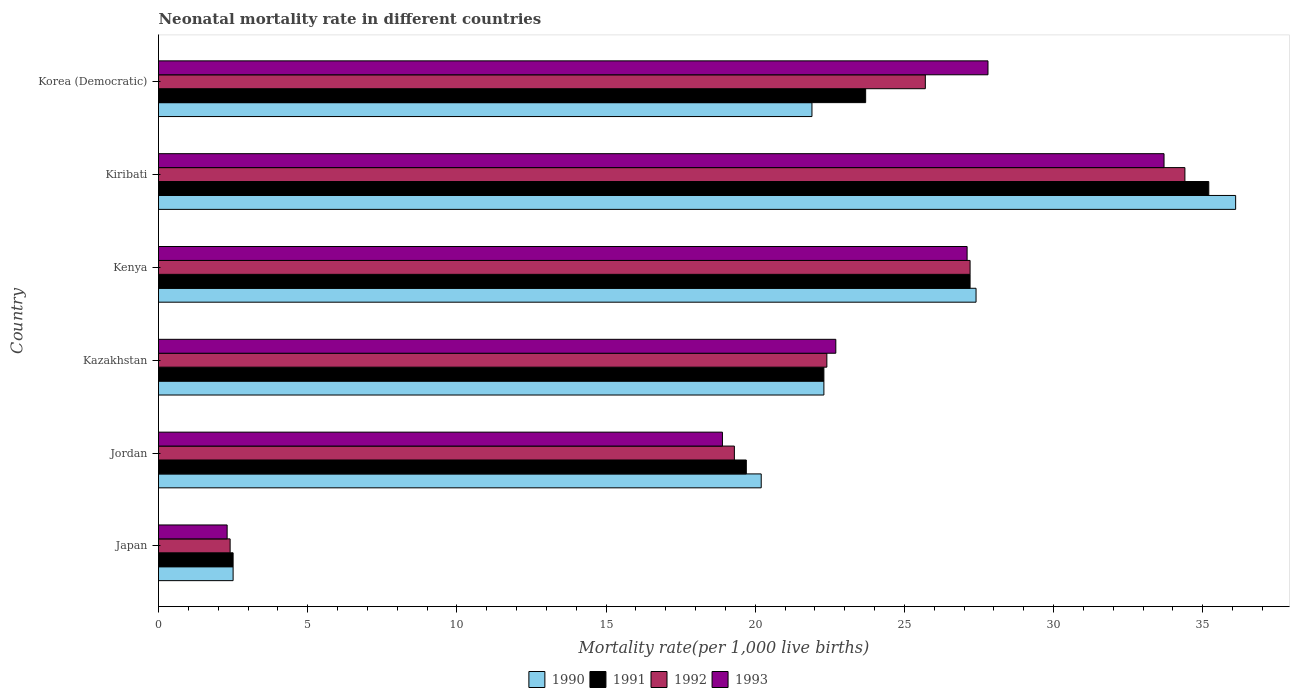Are the number of bars per tick equal to the number of legend labels?
Your response must be concise. Yes. How many bars are there on the 1st tick from the bottom?
Give a very brief answer. 4. What is the label of the 5th group of bars from the top?
Provide a succinct answer. Jordan. What is the neonatal mortality rate in 1992 in Jordan?
Keep it short and to the point. 19.3. Across all countries, what is the maximum neonatal mortality rate in 1993?
Give a very brief answer. 33.7. Across all countries, what is the minimum neonatal mortality rate in 1991?
Offer a terse response. 2.5. In which country was the neonatal mortality rate in 1993 maximum?
Offer a terse response. Kiribati. What is the total neonatal mortality rate in 1993 in the graph?
Provide a succinct answer. 132.5. What is the difference between the neonatal mortality rate in 1991 in Japan and that in Jordan?
Your response must be concise. -17.2. What is the average neonatal mortality rate in 1990 per country?
Make the answer very short. 21.73. What is the difference between the neonatal mortality rate in 1991 and neonatal mortality rate in 1992 in Kenya?
Your answer should be compact. 0. What is the ratio of the neonatal mortality rate in 1993 in Kenya to that in Korea (Democratic)?
Your response must be concise. 0.97. Is the neonatal mortality rate in 1990 in Jordan less than that in Korea (Democratic)?
Provide a short and direct response. Yes. Is the difference between the neonatal mortality rate in 1991 in Japan and Kazakhstan greater than the difference between the neonatal mortality rate in 1992 in Japan and Kazakhstan?
Your answer should be compact. Yes. What is the difference between the highest and the second highest neonatal mortality rate in 1992?
Give a very brief answer. 7.2. What is the difference between the highest and the lowest neonatal mortality rate in 1993?
Keep it short and to the point. 31.4. In how many countries, is the neonatal mortality rate in 1993 greater than the average neonatal mortality rate in 1993 taken over all countries?
Your response must be concise. 4. Is the sum of the neonatal mortality rate in 1993 in Kenya and Kiribati greater than the maximum neonatal mortality rate in 1992 across all countries?
Offer a terse response. Yes. What does the 3rd bar from the bottom in Japan represents?
Ensure brevity in your answer.  1992. Is it the case that in every country, the sum of the neonatal mortality rate in 1990 and neonatal mortality rate in 1992 is greater than the neonatal mortality rate in 1991?
Provide a short and direct response. Yes. What is the difference between two consecutive major ticks on the X-axis?
Your answer should be compact. 5. Does the graph contain grids?
Give a very brief answer. No. How many legend labels are there?
Offer a terse response. 4. What is the title of the graph?
Keep it short and to the point. Neonatal mortality rate in different countries. Does "2000" appear as one of the legend labels in the graph?
Provide a short and direct response. No. What is the label or title of the X-axis?
Provide a succinct answer. Mortality rate(per 1,0 live births). What is the label or title of the Y-axis?
Make the answer very short. Country. What is the Mortality rate(per 1,000 live births) of 1990 in Japan?
Offer a terse response. 2.5. What is the Mortality rate(per 1,000 live births) in 1993 in Japan?
Keep it short and to the point. 2.3. What is the Mortality rate(per 1,000 live births) in 1990 in Jordan?
Ensure brevity in your answer.  20.2. What is the Mortality rate(per 1,000 live births) of 1991 in Jordan?
Offer a very short reply. 19.7. What is the Mortality rate(per 1,000 live births) in 1992 in Jordan?
Give a very brief answer. 19.3. What is the Mortality rate(per 1,000 live births) of 1990 in Kazakhstan?
Give a very brief answer. 22.3. What is the Mortality rate(per 1,000 live births) in 1991 in Kazakhstan?
Your answer should be compact. 22.3. What is the Mortality rate(per 1,000 live births) in 1992 in Kazakhstan?
Your answer should be compact. 22.4. What is the Mortality rate(per 1,000 live births) in 1993 in Kazakhstan?
Provide a succinct answer. 22.7. What is the Mortality rate(per 1,000 live births) of 1990 in Kenya?
Provide a short and direct response. 27.4. What is the Mortality rate(per 1,000 live births) of 1991 in Kenya?
Your answer should be very brief. 27.2. What is the Mortality rate(per 1,000 live births) in 1992 in Kenya?
Make the answer very short. 27.2. What is the Mortality rate(per 1,000 live births) of 1993 in Kenya?
Make the answer very short. 27.1. What is the Mortality rate(per 1,000 live births) in 1990 in Kiribati?
Give a very brief answer. 36.1. What is the Mortality rate(per 1,000 live births) in 1991 in Kiribati?
Keep it short and to the point. 35.2. What is the Mortality rate(per 1,000 live births) in 1992 in Kiribati?
Provide a short and direct response. 34.4. What is the Mortality rate(per 1,000 live births) in 1993 in Kiribati?
Your response must be concise. 33.7. What is the Mortality rate(per 1,000 live births) in 1990 in Korea (Democratic)?
Provide a succinct answer. 21.9. What is the Mortality rate(per 1,000 live births) in 1991 in Korea (Democratic)?
Provide a succinct answer. 23.7. What is the Mortality rate(per 1,000 live births) of 1992 in Korea (Democratic)?
Ensure brevity in your answer.  25.7. What is the Mortality rate(per 1,000 live births) in 1993 in Korea (Democratic)?
Your response must be concise. 27.8. Across all countries, what is the maximum Mortality rate(per 1,000 live births) in 1990?
Your answer should be compact. 36.1. Across all countries, what is the maximum Mortality rate(per 1,000 live births) of 1991?
Keep it short and to the point. 35.2. Across all countries, what is the maximum Mortality rate(per 1,000 live births) of 1992?
Your answer should be compact. 34.4. Across all countries, what is the maximum Mortality rate(per 1,000 live births) in 1993?
Offer a terse response. 33.7. Across all countries, what is the minimum Mortality rate(per 1,000 live births) in 1990?
Make the answer very short. 2.5. What is the total Mortality rate(per 1,000 live births) in 1990 in the graph?
Your answer should be very brief. 130.4. What is the total Mortality rate(per 1,000 live births) of 1991 in the graph?
Provide a succinct answer. 130.6. What is the total Mortality rate(per 1,000 live births) of 1992 in the graph?
Give a very brief answer. 131.4. What is the total Mortality rate(per 1,000 live births) of 1993 in the graph?
Your answer should be very brief. 132.5. What is the difference between the Mortality rate(per 1,000 live births) in 1990 in Japan and that in Jordan?
Provide a succinct answer. -17.7. What is the difference between the Mortality rate(per 1,000 live births) of 1991 in Japan and that in Jordan?
Your response must be concise. -17.2. What is the difference between the Mortality rate(per 1,000 live births) in 1992 in Japan and that in Jordan?
Your response must be concise. -16.9. What is the difference between the Mortality rate(per 1,000 live births) in 1993 in Japan and that in Jordan?
Keep it short and to the point. -16.6. What is the difference between the Mortality rate(per 1,000 live births) of 1990 in Japan and that in Kazakhstan?
Give a very brief answer. -19.8. What is the difference between the Mortality rate(per 1,000 live births) in 1991 in Japan and that in Kazakhstan?
Your answer should be very brief. -19.8. What is the difference between the Mortality rate(per 1,000 live births) of 1992 in Japan and that in Kazakhstan?
Offer a very short reply. -20. What is the difference between the Mortality rate(per 1,000 live births) in 1993 in Japan and that in Kazakhstan?
Give a very brief answer. -20.4. What is the difference between the Mortality rate(per 1,000 live births) of 1990 in Japan and that in Kenya?
Your response must be concise. -24.9. What is the difference between the Mortality rate(per 1,000 live births) of 1991 in Japan and that in Kenya?
Offer a very short reply. -24.7. What is the difference between the Mortality rate(per 1,000 live births) of 1992 in Japan and that in Kenya?
Give a very brief answer. -24.8. What is the difference between the Mortality rate(per 1,000 live births) in 1993 in Japan and that in Kenya?
Your response must be concise. -24.8. What is the difference between the Mortality rate(per 1,000 live births) in 1990 in Japan and that in Kiribati?
Provide a short and direct response. -33.6. What is the difference between the Mortality rate(per 1,000 live births) in 1991 in Japan and that in Kiribati?
Your response must be concise. -32.7. What is the difference between the Mortality rate(per 1,000 live births) in 1992 in Japan and that in Kiribati?
Provide a short and direct response. -32. What is the difference between the Mortality rate(per 1,000 live births) of 1993 in Japan and that in Kiribati?
Your response must be concise. -31.4. What is the difference between the Mortality rate(per 1,000 live births) of 1990 in Japan and that in Korea (Democratic)?
Ensure brevity in your answer.  -19.4. What is the difference between the Mortality rate(per 1,000 live births) of 1991 in Japan and that in Korea (Democratic)?
Your response must be concise. -21.2. What is the difference between the Mortality rate(per 1,000 live births) in 1992 in Japan and that in Korea (Democratic)?
Ensure brevity in your answer.  -23.3. What is the difference between the Mortality rate(per 1,000 live births) in 1993 in Japan and that in Korea (Democratic)?
Provide a succinct answer. -25.5. What is the difference between the Mortality rate(per 1,000 live births) in 1990 in Jordan and that in Kazakhstan?
Give a very brief answer. -2.1. What is the difference between the Mortality rate(per 1,000 live births) in 1991 in Jordan and that in Kazakhstan?
Offer a very short reply. -2.6. What is the difference between the Mortality rate(per 1,000 live births) of 1992 in Jordan and that in Kazakhstan?
Provide a short and direct response. -3.1. What is the difference between the Mortality rate(per 1,000 live births) in 1991 in Jordan and that in Kenya?
Make the answer very short. -7.5. What is the difference between the Mortality rate(per 1,000 live births) in 1992 in Jordan and that in Kenya?
Offer a very short reply. -7.9. What is the difference between the Mortality rate(per 1,000 live births) in 1993 in Jordan and that in Kenya?
Your answer should be very brief. -8.2. What is the difference between the Mortality rate(per 1,000 live births) of 1990 in Jordan and that in Kiribati?
Your answer should be compact. -15.9. What is the difference between the Mortality rate(per 1,000 live births) in 1991 in Jordan and that in Kiribati?
Offer a terse response. -15.5. What is the difference between the Mortality rate(per 1,000 live births) of 1992 in Jordan and that in Kiribati?
Keep it short and to the point. -15.1. What is the difference between the Mortality rate(per 1,000 live births) in 1993 in Jordan and that in Kiribati?
Make the answer very short. -14.8. What is the difference between the Mortality rate(per 1,000 live births) of 1990 in Jordan and that in Korea (Democratic)?
Your answer should be compact. -1.7. What is the difference between the Mortality rate(per 1,000 live births) in 1991 in Jordan and that in Korea (Democratic)?
Ensure brevity in your answer.  -4. What is the difference between the Mortality rate(per 1,000 live births) of 1992 in Kazakhstan and that in Kenya?
Offer a terse response. -4.8. What is the difference between the Mortality rate(per 1,000 live births) in 1992 in Kazakhstan and that in Kiribati?
Give a very brief answer. -12. What is the difference between the Mortality rate(per 1,000 live births) in 1993 in Kazakhstan and that in Kiribati?
Provide a succinct answer. -11. What is the difference between the Mortality rate(per 1,000 live births) in 1990 in Kazakhstan and that in Korea (Democratic)?
Offer a terse response. 0.4. What is the difference between the Mortality rate(per 1,000 live births) in 1991 in Kazakhstan and that in Korea (Democratic)?
Offer a terse response. -1.4. What is the difference between the Mortality rate(per 1,000 live births) of 1992 in Kazakhstan and that in Korea (Democratic)?
Your response must be concise. -3.3. What is the difference between the Mortality rate(per 1,000 live births) in 1993 in Kazakhstan and that in Korea (Democratic)?
Provide a succinct answer. -5.1. What is the difference between the Mortality rate(per 1,000 live births) in 1992 in Kenya and that in Kiribati?
Make the answer very short. -7.2. What is the difference between the Mortality rate(per 1,000 live births) of 1993 in Kenya and that in Kiribati?
Offer a terse response. -6.6. What is the difference between the Mortality rate(per 1,000 live births) of 1991 in Kenya and that in Korea (Democratic)?
Your answer should be very brief. 3.5. What is the difference between the Mortality rate(per 1,000 live births) of 1992 in Kenya and that in Korea (Democratic)?
Keep it short and to the point. 1.5. What is the difference between the Mortality rate(per 1,000 live births) in 1993 in Kenya and that in Korea (Democratic)?
Offer a terse response. -0.7. What is the difference between the Mortality rate(per 1,000 live births) in 1991 in Kiribati and that in Korea (Democratic)?
Your answer should be very brief. 11.5. What is the difference between the Mortality rate(per 1,000 live births) of 1993 in Kiribati and that in Korea (Democratic)?
Your response must be concise. 5.9. What is the difference between the Mortality rate(per 1,000 live births) of 1990 in Japan and the Mortality rate(per 1,000 live births) of 1991 in Jordan?
Your answer should be compact. -17.2. What is the difference between the Mortality rate(per 1,000 live births) of 1990 in Japan and the Mortality rate(per 1,000 live births) of 1992 in Jordan?
Ensure brevity in your answer.  -16.8. What is the difference between the Mortality rate(per 1,000 live births) in 1990 in Japan and the Mortality rate(per 1,000 live births) in 1993 in Jordan?
Provide a short and direct response. -16.4. What is the difference between the Mortality rate(per 1,000 live births) in 1991 in Japan and the Mortality rate(per 1,000 live births) in 1992 in Jordan?
Your answer should be compact. -16.8. What is the difference between the Mortality rate(per 1,000 live births) in 1991 in Japan and the Mortality rate(per 1,000 live births) in 1993 in Jordan?
Offer a very short reply. -16.4. What is the difference between the Mortality rate(per 1,000 live births) in 1992 in Japan and the Mortality rate(per 1,000 live births) in 1993 in Jordan?
Make the answer very short. -16.5. What is the difference between the Mortality rate(per 1,000 live births) of 1990 in Japan and the Mortality rate(per 1,000 live births) of 1991 in Kazakhstan?
Offer a very short reply. -19.8. What is the difference between the Mortality rate(per 1,000 live births) of 1990 in Japan and the Mortality rate(per 1,000 live births) of 1992 in Kazakhstan?
Provide a short and direct response. -19.9. What is the difference between the Mortality rate(per 1,000 live births) of 1990 in Japan and the Mortality rate(per 1,000 live births) of 1993 in Kazakhstan?
Your answer should be very brief. -20.2. What is the difference between the Mortality rate(per 1,000 live births) in 1991 in Japan and the Mortality rate(per 1,000 live births) in 1992 in Kazakhstan?
Offer a very short reply. -19.9. What is the difference between the Mortality rate(per 1,000 live births) in 1991 in Japan and the Mortality rate(per 1,000 live births) in 1993 in Kazakhstan?
Provide a succinct answer. -20.2. What is the difference between the Mortality rate(per 1,000 live births) in 1992 in Japan and the Mortality rate(per 1,000 live births) in 1993 in Kazakhstan?
Offer a terse response. -20.3. What is the difference between the Mortality rate(per 1,000 live births) in 1990 in Japan and the Mortality rate(per 1,000 live births) in 1991 in Kenya?
Make the answer very short. -24.7. What is the difference between the Mortality rate(per 1,000 live births) of 1990 in Japan and the Mortality rate(per 1,000 live births) of 1992 in Kenya?
Ensure brevity in your answer.  -24.7. What is the difference between the Mortality rate(per 1,000 live births) in 1990 in Japan and the Mortality rate(per 1,000 live births) in 1993 in Kenya?
Offer a very short reply. -24.6. What is the difference between the Mortality rate(per 1,000 live births) in 1991 in Japan and the Mortality rate(per 1,000 live births) in 1992 in Kenya?
Provide a short and direct response. -24.7. What is the difference between the Mortality rate(per 1,000 live births) of 1991 in Japan and the Mortality rate(per 1,000 live births) of 1993 in Kenya?
Your answer should be compact. -24.6. What is the difference between the Mortality rate(per 1,000 live births) of 1992 in Japan and the Mortality rate(per 1,000 live births) of 1993 in Kenya?
Ensure brevity in your answer.  -24.7. What is the difference between the Mortality rate(per 1,000 live births) of 1990 in Japan and the Mortality rate(per 1,000 live births) of 1991 in Kiribati?
Your answer should be very brief. -32.7. What is the difference between the Mortality rate(per 1,000 live births) of 1990 in Japan and the Mortality rate(per 1,000 live births) of 1992 in Kiribati?
Your answer should be compact. -31.9. What is the difference between the Mortality rate(per 1,000 live births) in 1990 in Japan and the Mortality rate(per 1,000 live births) in 1993 in Kiribati?
Ensure brevity in your answer.  -31.2. What is the difference between the Mortality rate(per 1,000 live births) of 1991 in Japan and the Mortality rate(per 1,000 live births) of 1992 in Kiribati?
Offer a terse response. -31.9. What is the difference between the Mortality rate(per 1,000 live births) of 1991 in Japan and the Mortality rate(per 1,000 live births) of 1993 in Kiribati?
Give a very brief answer. -31.2. What is the difference between the Mortality rate(per 1,000 live births) in 1992 in Japan and the Mortality rate(per 1,000 live births) in 1993 in Kiribati?
Keep it short and to the point. -31.3. What is the difference between the Mortality rate(per 1,000 live births) in 1990 in Japan and the Mortality rate(per 1,000 live births) in 1991 in Korea (Democratic)?
Your answer should be compact. -21.2. What is the difference between the Mortality rate(per 1,000 live births) of 1990 in Japan and the Mortality rate(per 1,000 live births) of 1992 in Korea (Democratic)?
Provide a short and direct response. -23.2. What is the difference between the Mortality rate(per 1,000 live births) in 1990 in Japan and the Mortality rate(per 1,000 live births) in 1993 in Korea (Democratic)?
Your response must be concise. -25.3. What is the difference between the Mortality rate(per 1,000 live births) of 1991 in Japan and the Mortality rate(per 1,000 live births) of 1992 in Korea (Democratic)?
Offer a very short reply. -23.2. What is the difference between the Mortality rate(per 1,000 live births) in 1991 in Japan and the Mortality rate(per 1,000 live births) in 1993 in Korea (Democratic)?
Give a very brief answer. -25.3. What is the difference between the Mortality rate(per 1,000 live births) in 1992 in Japan and the Mortality rate(per 1,000 live births) in 1993 in Korea (Democratic)?
Keep it short and to the point. -25.4. What is the difference between the Mortality rate(per 1,000 live births) of 1990 in Jordan and the Mortality rate(per 1,000 live births) of 1991 in Kazakhstan?
Provide a short and direct response. -2.1. What is the difference between the Mortality rate(per 1,000 live births) of 1990 in Jordan and the Mortality rate(per 1,000 live births) of 1992 in Kazakhstan?
Give a very brief answer. -2.2. What is the difference between the Mortality rate(per 1,000 live births) in 1990 in Jordan and the Mortality rate(per 1,000 live births) in 1993 in Kazakhstan?
Your answer should be very brief. -2.5. What is the difference between the Mortality rate(per 1,000 live births) of 1991 in Jordan and the Mortality rate(per 1,000 live births) of 1992 in Kazakhstan?
Your answer should be compact. -2.7. What is the difference between the Mortality rate(per 1,000 live births) of 1991 in Jordan and the Mortality rate(per 1,000 live births) of 1993 in Kazakhstan?
Offer a very short reply. -3. What is the difference between the Mortality rate(per 1,000 live births) of 1992 in Jordan and the Mortality rate(per 1,000 live births) of 1993 in Kazakhstan?
Make the answer very short. -3.4. What is the difference between the Mortality rate(per 1,000 live births) of 1990 in Jordan and the Mortality rate(per 1,000 live births) of 1991 in Kenya?
Provide a succinct answer. -7. What is the difference between the Mortality rate(per 1,000 live births) of 1990 in Jordan and the Mortality rate(per 1,000 live births) of 1993 in Kenya?
Your answer should be very brief. -6.9. What is the difference between the Mortality rate(per 1,000 live births) in 1991 in Jordan and the Mortality rate(per 1,000 live births) in 1992 in Kenya?
Give a very brief answer. -7.5. What is the difference between the Mortality rate(per 1,000 live births) in 1992 in Jordan and the Mortality rate(per 1,000 live births) in 1993 in Kenya?
Your answer should be compact. -7.8. What is the difference between the Mortality rate(per 1,000 live births) of 1990 in Jordan and the Mortality rate(per 1,000 live births) of 1992 in Kiribati?
Offer a terse response. -14.2. What is the difference between the Mortality rate(per 1,000 live births) of 1991 in Jordan and the Mortality rate(per 1,000 live births) of 1992 in Kiribati?
Give a very brief answer. -14.7. What is the difference between the Mortality rate(per 1,000 live births) of 1991 in Jordan and the Mortality rate(per 1,000 live births) of 1993 in Kiribati?
Provide a short and direct response. -14. What is the difference between the Mortality rate(per 1,000 live births) in 1992 in Jordan and the Mortality rate(per 1,000 live births) in 1993 in Kiribati?
Keep it short and to the point. -14.4. What is the difference between the Mortality rate(per 1,000 live births) of 1990 in Jordan and the Mortality rate(per 1,000 live births) of 1991 in Korea (Democratic)?
Your answer should be very brief. -3.5. What is the difference between the Mortality rate(per 1,000 live births) of 1991 in Jordan and the Mortality rate(per 1,000 live births) of 1992 in Korea (Democratic)?
Ensure brevity in your answer.  -6. What is the difference between the Mortality rate(per 1,000 live births) in 1990 in Kazakhstan and the Mortality rate(per 1,000 live births) in 1991 in Kenya?
Give a very brief answer. -4.9. What is the difference between the Mortality rate(per 1,000 live births) of 1990 in Kazakhstan and the Mortality rate(per 1,000 live births) of 1993 in Kenya?
Your response must be concise. -4.8. What is the difference between the Mortality rate(per 1,000 live births) of 1991 in Kazakhstan and the Mortality rate(per 1,000 live births) of 1992 in Kenya?
Make the answer very short. -4.9. What is the difference between the Mortality rate(per 1,000 live births) in 1991 in Kazakhstan and the Mortality rate(per 1,000 live births) in 1993 in Kenya?
Your response must be concise. -4.8. What is the difference between the Mortality rate(per 1,000 live births) of 1990 in Kazakhstan and the Mortality rate(per 1,000 live births) of 1991 in Kiribati?
Keep it short and to the point. -12.9. What is the difference between the Mortality rate(per 1,000 live births) in 1990 in Kazakhstan and the Mortality rate(per 1,000 live births) in 1993 in Kiribati?
Make the answer very short. -11.4. What is the difference between the Mortality rate(per 1,000 live births) of 1991 in Kazakhstan and the Mortality rate(per 1,000 live births) of 1993 in Kiribati?
Your answer should be compact. -11.4. What is the difference between the Mortality rate(per 1,000 live births) of 1992 in Kazakhstan and the Mortality rate(per 1,000 live births) of 1993 in Kiribati?
Your answer should be compact. -11.3. What is the difference between the Mortality rate(per 1,000 live births) in 1990 in Kazakhstan and the Mortality rate(per 1,000 live births) in 1993 in Korea (Democratic)?
Offer a terse response. -5.5. What is the difference between the Mortality rate(per 1,000 live births) in 1991 in Kazakhstan and the Mortality rate(per 1,000 live births) in 1992 in Korea (Democratic)?
Offer a terse response. -3.4. What is the difference between the Mortality rate(per 1,000 live births) of 1991 in Kazakhstan and the Mortality rate(per 1,000 live births) of 1993 in Korea (Democratic)?
Your response must be concise. -5.5. What is the difference between the Mortality rate(per 1,000 live births) of 1992 in Kazakhstan and the Mortality rate(per 1,000 live births) of 1993 in Korea (Democratic)?
Offer a very short reply. -5.4. What is the difference between the Mortality rate(per 1,000 live births) in 1990 in Kenya and the Mortality rate(per 1,000 live births) in 1991 in Kiribati?
Ensure brevity in your answer.  -7.8. What is the difference between the Mortality rate(per 1,000 live births) in 1992 in Kenya and the Mortality rate(per 1,000 live births) in 1993 in Kiribati?
Provide a short and direct response. -6.5. What is the difference between the Mortality rate(per 1,000 live births) in 1990 in Kenya and the Mortality rate(per 1,000 live births) in 1991 in Korea (Democratic)?
Keep it short and to the point. 3.7. What is the difference between the Mortality rate(per 1,000 live births) of 1991 in Kenya and the Mortality rate(per 1,000 live births) of 1992 in Korea (Democratic)?
Provide a succinct answer. 1.5. What is the difference between the Mortality rate(per 1,000 live births) of 1991 in Kenya and the Mortality rate(per 1,000 live births) of 1993 in Korea (Democratic)?
Your response must be concise. -0.6. What is the difference between the Mortality rate(per 1,000 live births) of 1990 in Kiribati and the Mortality rate(per 1,000 live births) of 1991 in Korea (Democratic)?
Offer a terse response. 12.4. What is the difference between the Mortality rate(per 1,000 live births) of 1990 in Kiribati and the Mortality rate(per 1,000 live births) of 1992 in Korea (Democratic)?
Provide a succinct answer. 10.4. What is the difference between the Mortality rate(per 1,000 live births) of 1990 in Kiribati and the Mortality rate(per 1,000 live births) of 1993 in Korea (Democratic)?
Provide a succinct answer. 8.3. What is the average Mortality rate(per 1,000 live births) of 1990 per country?
Provide a short and direct response. 21.73. What is the average Mortality rate(per 1,000 live births) of 1991 per country?
Your answer should be very brief. 21.77. What is the average Mortality rate(per 1,000 live births) of 1992 per country?
Keep it short and to the point. 21.9. What is the average Mortality rate(per 1,000 live births) of 1993 per country?
Offer a terse response. 22.08. What is the difference between the Mortality rate(per 1,000 live births) of 1990 and Mortality rate(per 1,000 live births) of 1991 in Japan?
Give a very brief answer. 0. What is the difference between the Mortality rate(per 1,000 live births) in 1990 and Mortality rate(per 1,000 live births) in 1992 in Japan?
Provide a succinct answer. 0.1. What is the difference between the Mortality rate(per 1,000 live births) in 1991 and Mortality rate(per 1,000 live births) in 1993 in Japan?
Ensure brevity in your answer.  0.2. What is the difference between the Mortality rate(per 1,000 live births) in 1992 and Mortality rate(per 1,000 live births) in 1993 in Japan?
Your answer should be very brief. 0.1. What is the difference between the Mortality rate(per 1,000 live births) in 1990 and Mortality rate(per 1,000 live births) in 1992 in Jordan?
Offer a very short reply. 0.9. What is the difference between the Mortality rate(per 1,000 live births) in 1991 and Mortality rate(per 1,000 live births) in 1992 in Jordan?
Offer a very short reply. 0.4. What is the difference between the Mortality rate(per 1,000 live births) of 1991 and Mortality rate(per 1,000 live births) of 1993 in Jordan?
Give a very brief answer. 0.8. What is the difference between the Mortality rate(per 1,000 live births) of 1990 and Mortality rate(per 1,000 live births) of 1992 in Kazakhstan?
Offer a very short reply. -0.1. What is the difference between the Mortality rate(per 1,000 live births) in 1990 and Mortality rate(per 1,000 live births) in 1993 in Kazakhstan?
Ensure brevity in your answer.  -0.4. What is the difference between the Mortality rate(per 1,000 live births) in 1991 and Mortality rate(per 1,000 live births) in 1992 in Kazakhstan?
Give a very brief answer. -0.1. What is the difference between the Mortality rate(per 1,000 live births) in 1992 and Mortality rate(per 1,000 live births) in 1993 in Kazakhstan?
Your response must be concise. -0.3. What is the difference between the Mortality rate(per 1,000 live births) in 1990 and Mortality rate(per 1,000 live births) in 1992 in Kenya?
Provide a short and direct response. 0.2. What is the difference between the Mortality rate(per 1,000 live births) in 1991 and Mortality rate(per 1,000 live births) in 1993 in Kenya?
Provide a short and direct response. 0.1. What is the difference between the Mortality rate(per 1,000 live births) of 1990 and Mortality rate(per 1,000 live births) of 1991 in Kiribati?
Provide a short and direct response. 0.9. What is the difference between the Mortality rate(per 1,000 live births) in 1991 and Mortality rate(per 1,000 live births) in 1992 in Kiribati?
Make the answer very short. 0.8. What is the difference between the Mortality rate(per 1,000 live births) of 1991 and Mortality rate(per 1,000 live births) of 1993 in Kiribati?
Make the answer very short. 1.5. What is the difference between the Mortality rate(per 1,000 live births) of 1990 and Mortality rate(per 1,000 live births) of 1992 in Korea (Democratic)?
Offer a very short reply. -3.8. What is the difference between the Mortality rate(per 1,000 live births) in 1990 and Mortality rate(per 1,000 live births) in 1993 in Korea (Democratic)?
Your answer should be compact. -5.9. What is the difference between the Mortality rate(per 1,000 live births) in 1991 and Mortality rate(per 1,000 live births) in 1993 in Korea (Democratic)?
Keep it short and to the point. -4.1. What is the ratio of the Mortality rate(per 1,000 live births) in 1990 in Japan to that in Jordan?
Your response must be concise. 0.12. What is the ratio of the Mortality rate(per 1,000 live births) of 1991 in Japan to that in Jordan?
Keep it short and to the point. 0.13. What is the ratio of the Mortality rate(per 1,000 live births) in 1992 in Japan to that in Jordan?
Your answer should be compact. 0.12. What is the ratio of the Mortality rate(per 1,000 live births) in 1993 in Japan to that in Jordan?
Provide a succinct answer. 0.12. What is the ratio of the Mortality rate(per 1,000 live births) in 1990 in Japan to that in Kazakhstan?
Make the answer very short. 0.11. What is the ratio of the Mortality rate(per 1,000 live births) in 1991 in Japan to that in Kazakhstan?
Make the answer very short. 0.11. What is the ratio of the Mortality rate(per 1,000 live births) in 1992 in Japan to that in Kazakhstan?
Provide a short and direct response. 0.11. What is the ratio of the Mortality rate(per 1,000 live births) of 1993 in Japan to that in Kazakhstan?
Keep it short and to the point. 0.1. What is the ratio of the Mortality rate(per 1,000 live births) of 1990 in Japan to that in Kenya?
Your answer should be compact. 0.09. What is the ratio of the Mortality rate(per 1,000 live births) in 1991 in Japan to that in Kenya?
Ensure brevity in your answer.  0.09. What is the ratio of the Mortality rate(per 1,000 live births) in 1992 in Japan to that in Kenya?
Provide a short and direct response. 0.09. What is the ratio of the Mortality rate(per 1,000 live births) in 1993 in Japan to that in Kenya?
Provide a succinct answer. 0.08. What is the ratio of the Mortality rate(per 1,000 live births) of 1990 in Japan to that in Kiribati?
Make the answer very short. 0.07. What is the ratio of the Mortality rate(per 1,000 live births) of 1991 in Japan to that in Kiribati?
Keep it short and to the point. 0.07. What is the ratio of the Mortality rate(per 1,000 live births) of 1992 in Japan to that in Kiribati?
Provide a succinct answer. 0.07. What is the ratio of the Mortality rate(per 1,000 live births) of 1993 in Japan to that in Kiribati?
Ensure brevity in your answer.  0.07. What is the ratio of the Mortality rate(per 1,000 live births) in 1990 in Japan to that in Korea (Democratic)?
Ensure brevity in your answer.  0.11. What is the ratio of the Mortality rate(per 1,000 live births) in 1991 in Japan to that in Korea (Democratic)?
Ensure brevity in your answer.  0.11. What is the ratio of the Mortality rate(per 1,000 live births) in 1992 in Japan to that in Korea (Democratic)?
Provide a short and direct response. 0.09. What is the ratio of the Mortality rate(per 1,000 live births) of 1993 in Japan to that in Korea (Democratic)?
Give a very brief answer. 0.08. What is the ratio of the Mortality rate(per 1,000 live births) in 1990 in Jordan to that in Kazakhstan?
Your answer should be compact. 0.91. What is the ratio of the Mortality rate(per 1,000 live births) of 1991 in Jordan to that in Kazakhstan?
Provide a succinct answer. 0.88. What is the ratio of the Mortality rate(per 1,000 live births) in 1992 in Jordan to that in Kazakhstan?
Offer a terse response. 0.86. What is the ratio of the Mortality rate(per 1,000 live births) of 1993 in Jordan to that in Kazakhstan?
Offer a very short reply. 0.83. What is the ratio of the Mortality rate(per 1,000 live births) in 1990 in Jordan to that in Kenya?
Offer a very short reply. 0.74. What is the ratio of the Mortality rate(per 1,000 live births) of 1991 in Jordan to that in Kenya?
Provide a short and direct response. 0.72. What is the ratio of the Mortality rate(per 1,000 live births) of 1992 in Jordan to that in Kenya?
Provide a short and direct response. 0.71. What is the ratio of the Mortality rate(per 1,000 live births) of 1993 in Jordan to that in Kenya?
Make the answer very short. 0.7. What is the ratio of the Mortality rate(per 1,000 live births) of 1990 in Jordan to that in Kiribati?
Provide a short and direct response. 0.56. What is the ratio of the Mortality rate(per 1,000 live births) of 1991 in Jordan to that in Kiribati?
Provide a short and direct response. 0.56. What is the ratio of the Mortality rate(per 1,000 live births) of 1992 in Jordan to that in Kiribati?
Offer a very short reply. 0.56. What is the ratio of the Mortality rate(per 1,000 live births) of 1993 in Jordan to that in Kiribati?
Your answer should be compact. 0.56. What is the ratio of the Mortality rate(per 1,000 live births) in 1990 in Jordan to that in Korea (Democratic)?
Give a very brief answer. 0.92. What is the ratio of the Mortality rate(per 1,000 live births) of 1991 in Jordan to that in Korea (Democratic)?
Make the answer very short. 0.83. What is the ratio of the Mortality rate(per 1,000 live births) of 1992 in Jordan to that in Korea (Democratic)?
Give a very brief answer. 0.75. What is the ratio of the Mortality rate(per 1,000 live births) of 1993 in Jordan to that in Korea (Democratic)?
Provide a succinct answer. 0.68. What is the ratio of the Mortality rate(per 1,000 live births) of 1990 in Kazakhstan to that in Kenya?
Your answer should be very brief. 0.81. What is the ratio of the Mortality rate(per 1,000 live births) in 1991 in Kazakhstan to that in Kenya?
Offer a very short reply. 0.82. What is the ratio of the Mortality rate(per 1,000 live births) in 1992 in Kazakhstan to that in Kenya?
Provide a succinct answer. 0.82. What is the ratio of the Mortality rate(per 1,000 live births) in 1993 in Kazakhstan to that in Kenya?
Your answer should be very brief. 0.84. What is the ratio of the Mortality rate(per 1,000 live births) in 1990 in Kazakhstan to that in Kiribati?
Your answer should be very brief. 0.62. What is the ratio of the Mortality rate(per 1,000 live births) of 1991 in Kazakhstan to that in Kiribati?
Keep it short and to the point. 0.63. What is the ratio of the Mortality rate(per 1,000 live births) of 1992 in Kazakhstan to that in Kiribati?
Give a very brief answer. 0.65. What is the ratio of the Mortality rate(per 1,000 live births) of 1993 in Kazakhstan to that in Kiribati?
Offer a terse response. 0.67. What is the ratio of the Mortality rate(per 1,000 live births) of 1990 in Kazakhstan to that in Korea (Democratic)?
Your answer should be very brief. 1.02. What is the ratio of the Mortality rate(per 1,000 live births) in 1991 in Kazakhstan to that in Korea (Democratic)?
Your response must be concise. 0.94. What is the ratio of the Mortality rate(per 1,000 live births) in 1992 in Kazakhstan to that in Korea (Democratic)?
Your answer should be compact. 0.87. What is the ratio of the Mortality rate(per 1,000 live births) in 1993 in Kazakhstan to that in Korea (Democratic)?
Your answer should be very brief. 0.82. What is the ratio of the Mortality rate(per 1,000 live births) of 1990 in Kenya to that in Kiribati?
Provide a succinct answer. 0.76. What is the ratio of the Mortality rate(per 1,000 live births) of 1991 in Kenya to that in Kiribati?
Your answer should be compact. 0.77. What is the ratio of the Mortality rate(per 1,000 live births) of 1992 in Kenya to that in Kiribati?
Provide a succinct answer. 0.79. What is the ratio of the Mortality rate(per 1,000 live births) of 1993 in Kenya to that in Kiribati?
Your answer should be very brief. 0.8. What is the ratio of the Mortality rate(per 1,000 live births) in 1990 in Kenya to that in Korea (Democratic)?
Keep it short and to the point. 1.25. What is the ratio of the Mortality rate(per 1,000 live births) in 1991 in Kenya to that in Korea (Democratic)?
Ensure brevity in your answer.  1.15. What is the ratio of the Mortality rate(per 1,000 live births) of 1992 in Kenya to that in Korea (Democratic)?
Give a very brief answer. 1.06. What is the ratio of the Mortality rate(per 1,000 live births) in 1993 in Kenya to that in Korea (Democratic)?
Offer a terse response. 0.97. What is the ratio of the Mortality rate(per 1,000 live births) of 1990 in Kiribati to that in Korea (Democratic)?
Give a very brief answer. 1.65. What is the ratio of the Mortality rate(per 1,000 live births) of 1991 in Kiribati to that in Korea (Democratic)?
Give a very brief answer. 1.49. What is the ratio of the Mortality rate(per 1,000 live births) in 1992 in Kiribati to that in Korea (Democratic)?
Your response must be concise. 1.34. What is the ratio of the Mortality rate(per 1,000 live births) in 1993 in Kiribati to that in Korea (Democratic)?
Offer a terse response. 1.21. What is the difference between the highest and the second highest Mortality rate(per 1,000 live births) in 1990?
Offer a terse response. 8.7. What is the difference between the highest and the second highest Mortality rate(per 1,000 live births) of 1992?
Provide a short and direct response. 7.2. What is the difference between the highest and the second highest Mortality rate(per 1,000 live births) in 1993?
Make the answer very short. 5.9. What is the difference between the highest and the lowest Mortality rate(per 1,000 live births) in 1990?
Ensure brevity in your answer.  33.6. What is the difference between the highest and the lowest Mortality rate(per 1,000 live births) in 1991?
Provide a short and direct response. 32.7. What is the difference between the highest and the lowest Mortality rate(per 1,000 live births) of 1992?
Provide a short and direct response. 32. What is the difference between the highest and the lowest Mortality rate(per 1,000 live births) in 1993?
Give a very brief answer. 31.4. 